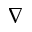<formula> <loc_0><loc_0><loc_500><loc_500>\nabla</formula> 